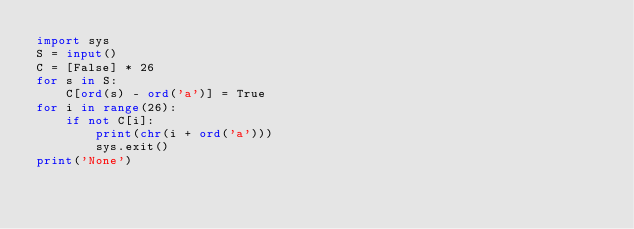<code> <loc_0><loc_0><loc_500><loc_500><_Python_>import sys
S = input()
C = [False] * 26
for s in S:
    C[ord(s) - ord('a')] = True
for i in range(26):
    if not C[i]:
        print(chr(i + ord('a')))
        sys.exit()
print('None')
</code> 